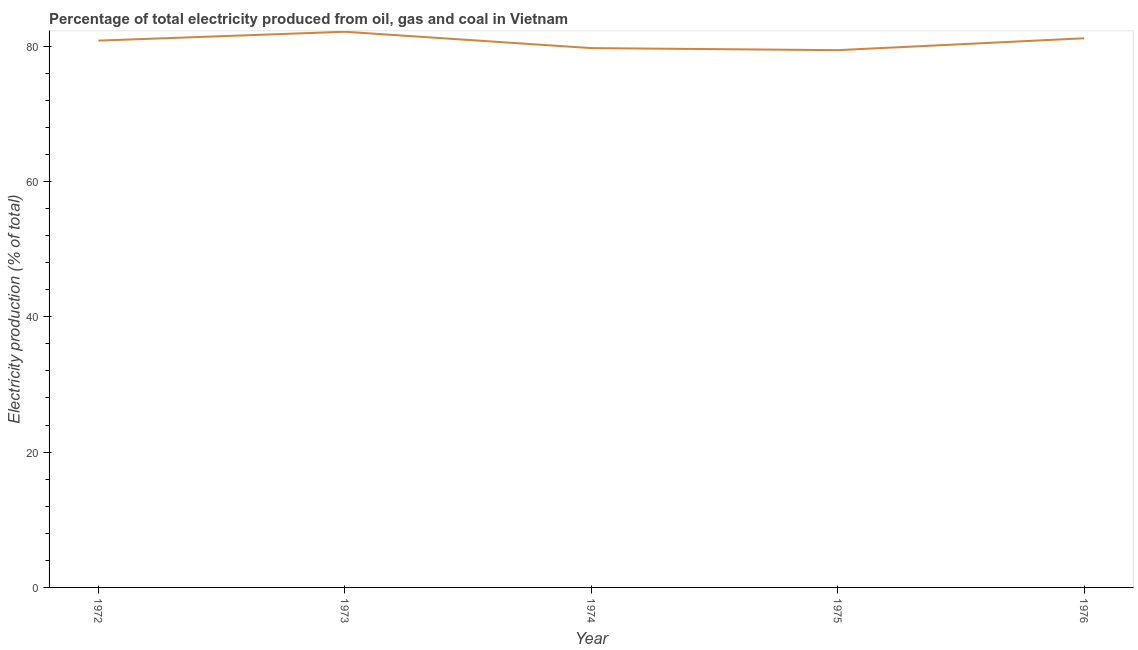What is the electricity production in 1973?
Make the answer very short. 82.13. Across all years, what is the maximum electricity production?
Provide a short and direct response. 82.13. Across all years, what is the minimum electricity production?
Your response must be concise. 79.41. In which year was the electricity production minimum?
Make the answer very short. 1975. What is the sum of the electricity production?
Offer a very short reply. 403.23. What is the difference between the electricity production in 1973 and 1976?
Offer a terse response. 0.96. What is the average electricity production per year?
Provide a succinct answer. 80.65. What is the median electricity production?
Provide a succinct answer. 80.82. Do a majority of the years between 1973 and 1976 (inclusive) have electricity production greater than 40 %?
Your answer should be compact. Yes. What is the ratio of the electricity production in 1975 to that in 1976?
Give a very brief answer. 0.98. Is the electricity production in 1972 less than that in 1974?
Ensure brevity in your answer.  No. What is the difference between the highest and the second highest electricity production?
Provide a short and direct response. 0.96. Is the sum of the electricity production in 1972 and 1974 greater than the maximum electricity production across all years?
Your answer should be compact. Yes. What is the difference between the highest and the lowest electricity production?
Provide a succinct answer. 2.72. In how many years, is the electricity production greater than the average electricity production taken over all years?
Keep it short and to the point. 3. Does the electricity production monotonically increase over the years?
Provide a short and direct response. No. How many lines are there?
Offer a very short reply. 1. Does the graph contain any zero values?
Offer a terse response. No. What is the title of the graph?
Provide a succinct answer. Percentage of total electricity produced from oil, gas and coal in Vietnam. What is the label or title of the X-axis?
Offer a terse response. Year. What is the label or title of the Y-axis?
Keep it short and to the point. Electricity production (% of total). What is the Electricity production (% of total) of 1972?
Make the answer very short. 80.82. What is the Electricity production (% of total) in 1973?
Your answer should be compact. 82.13. What is the Electricity production (% of total) in 1974?
Give a very brief answer. 79.71. What is the Electricity production (% of total) of 1975?
Keep it short and to the point. 79.41. What is the Electricity production (% of total) of 1976?
Make the answer very short. 81.16. What is the difference between the Electricity production (% of total) in 1972 and 1973?
Your response must be concise. -1.31. What is the difference between the Electricity production (% of total) in 1972 and 1974?
Your answer should be very brief. 1.11. What is the difference between the Electricity production (% of total) in 1972 and 1975?
Provide a short and direct response. 1.41. What is the difference between the Electricity production (% of total) in 1972 and 1976?
Provide a short and direct response. -0.35. What is the difference between the Electricity production (% of total) in 1973 and 1974?
Your answer should be very brief. 2.42. What is the difference between the Electricity production (% of total) in 1973 and 1975?
Your answer should be very brief. 2.72. What is the difference between the Electricity production (% of total) in 1973 and 1976?
Give a very brief answer. 0.96. What is the difference between the Electricity production (% of total) in 1974 and 1975?
Provide a short and direct response. 0.3. What is the difference between the Electricity production (% of total) in 1974 and 1976?
Offer a terse response. -1.45. What is the difference between the Electricity production (% of total) in 1975 and 1976?
Your answer should be compact. -1.76. What is the ratio of the Electricity production (% of total) in 1972 to that in 1973?
Make the answer very short. 0.98. What is the ratio of the Electricity production (% of total) in 1972 to that in 1974?
Your answer should be very brief. 1.01. What is the ratio of the Electricity production (% of total) in 1972 to that in 1976?
Your response must be concise. 1. What is the ratio of the Electricity production (% of total) in 1973 to that in 1975?
Give a very brief answer. 1.03. What is the ratio of the Electricity production (% of total) in 1973 to that in 1976?
Your response must be concise. 1.01. What is the ratio of the Electricity production (% of total) in 1974 to that in 1976?
Give a very brief answer. 0.98. What is the ratio of the Electricity production (% of total) in 1975 to that in 1976?
Provide a succinct answer. 0.98. 